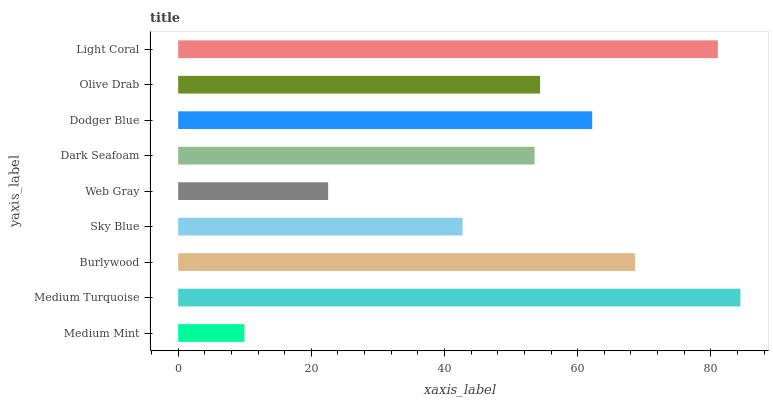Is Medium Mint the minimum?
Answer yes or no. Yes. Is Medium Turquoise the maximum?
Answer yes or no. Yes. Is Burlywood the minimum?
Answer yes or no. No. Is Burlywood the maximum?
Answer yes or no. No. Is Medium Turquoise greater than Burlywood?
Answer yes or no. Yes. Is Burlywood less than Medium Turquoise?
Answer yes or no. Yes. Is Burlywood greater than Medium Turquoise?
Answer yes or no. No. Is Medium Turquoise less than Burlywood?
Answer yes or no. No. Is Olive Drab the high median?
Answer yes or no. Yes. Is Olive Drab the low median?
Answer yes or no. Yes. Is Medium Turquoise the high median?
Answer yes or no. No. Is Sky Blue the low median?
Answer yes or no. No. 